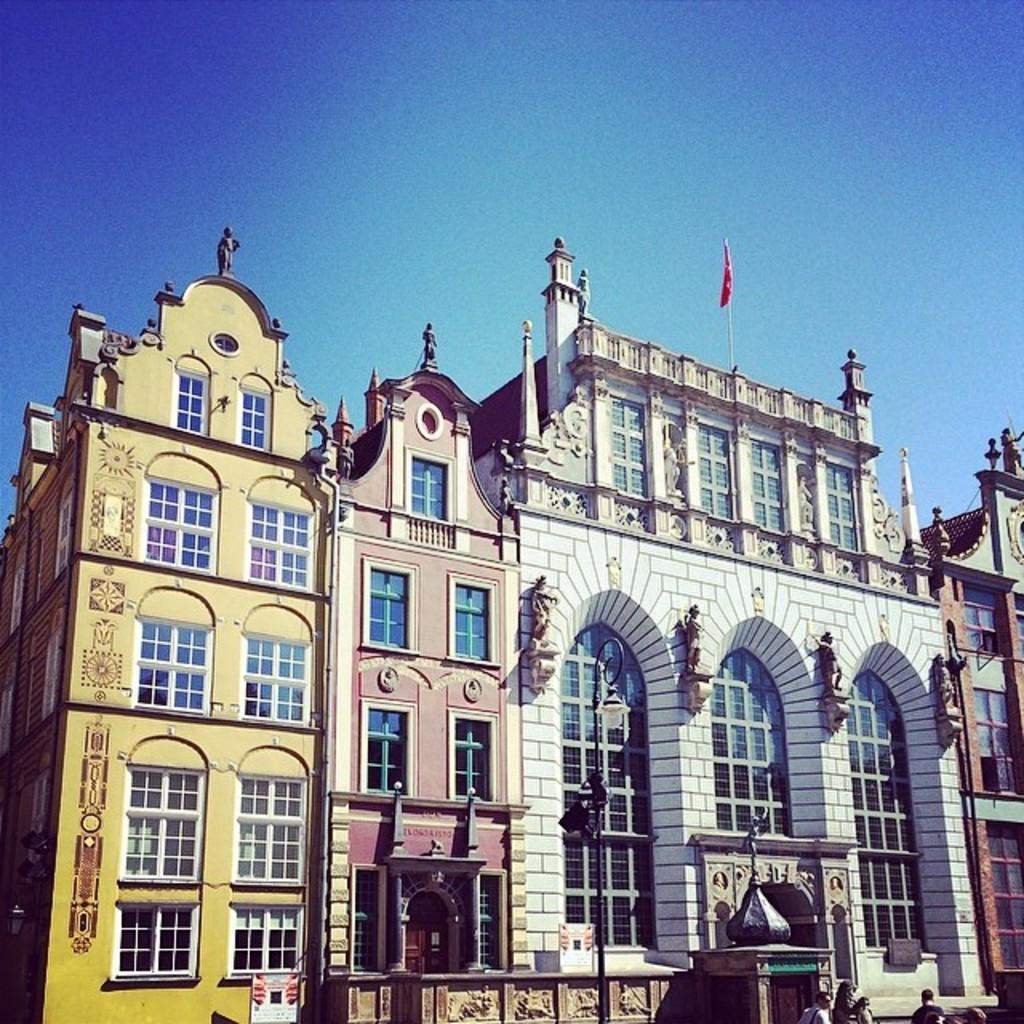What type of structures are located in the middle of the image? There are houses in the middle of the image. What feature do the houses have? The houses have windows. What is present in the image besides the houses? There is a wall, people at the bottom of the image, and the sky visible at the top of the image. What else can be seen in the image? There is a flag in the image. What type of corn can be seen growing on the curve of the record in the image? There is no corn or record present in the image. 